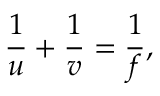Convert formula to latex. <formula><loc_0><loc_0><loc_500><loc_500>\frac { 1 } { u } + \frac { 1 } { v } = \frac { 1 } { f } ,</formula> 